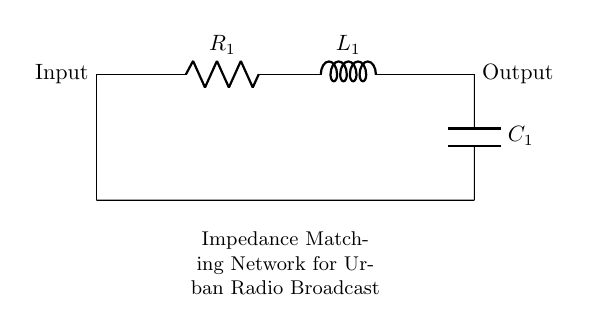What type of circuit is represented? The components in the circuit include a resistor, an inductor, and a capacitor, which are typically arranged for impedance matching. This indicates that it is an RLC circuit.
Answer: RLC circuit What component is directly connected to the input? The first component connected to the input terminal is the resistor, identified in the circuit diagram.
Answer: Resistor What is the output connection in the circuit? The circuit output connects to the capacitor, which is connected to the ground, completing the circuit path for the outgoing signal.
Answer: Capacitor What is the purpose of this circuit in urban radio broadcast? The primary purpose of this impedance matching network is to ensure that the signal is optimized for the load, facilitating better transmission in urban environments with varying impedances.
Answer: Impedance matching Which component affects the phase of the signal the most? The inductor primarily affects the phase of the signal due to its property of storing energy in a magnetic field and introducing reactance that varies with frequency.
Answer: Inductor What happens to the impedance if the frequency increases? As the frequency increases, the reactance of the inductor increases while that of the capacitor decreases, which can lead to a shift in overall circuit impedance, affecting signal quality and efficiency.
Answer: Increases What does the labeling "R1," "L1," and "C1" indicate? The labels "R1," "L1," and "C1" correspond to the first resistor, inductor, and capacitor in the circuit, respectively, which helps in identifying and configuring components in the circuit for analysis or adjustment.
Answer: Component identification 